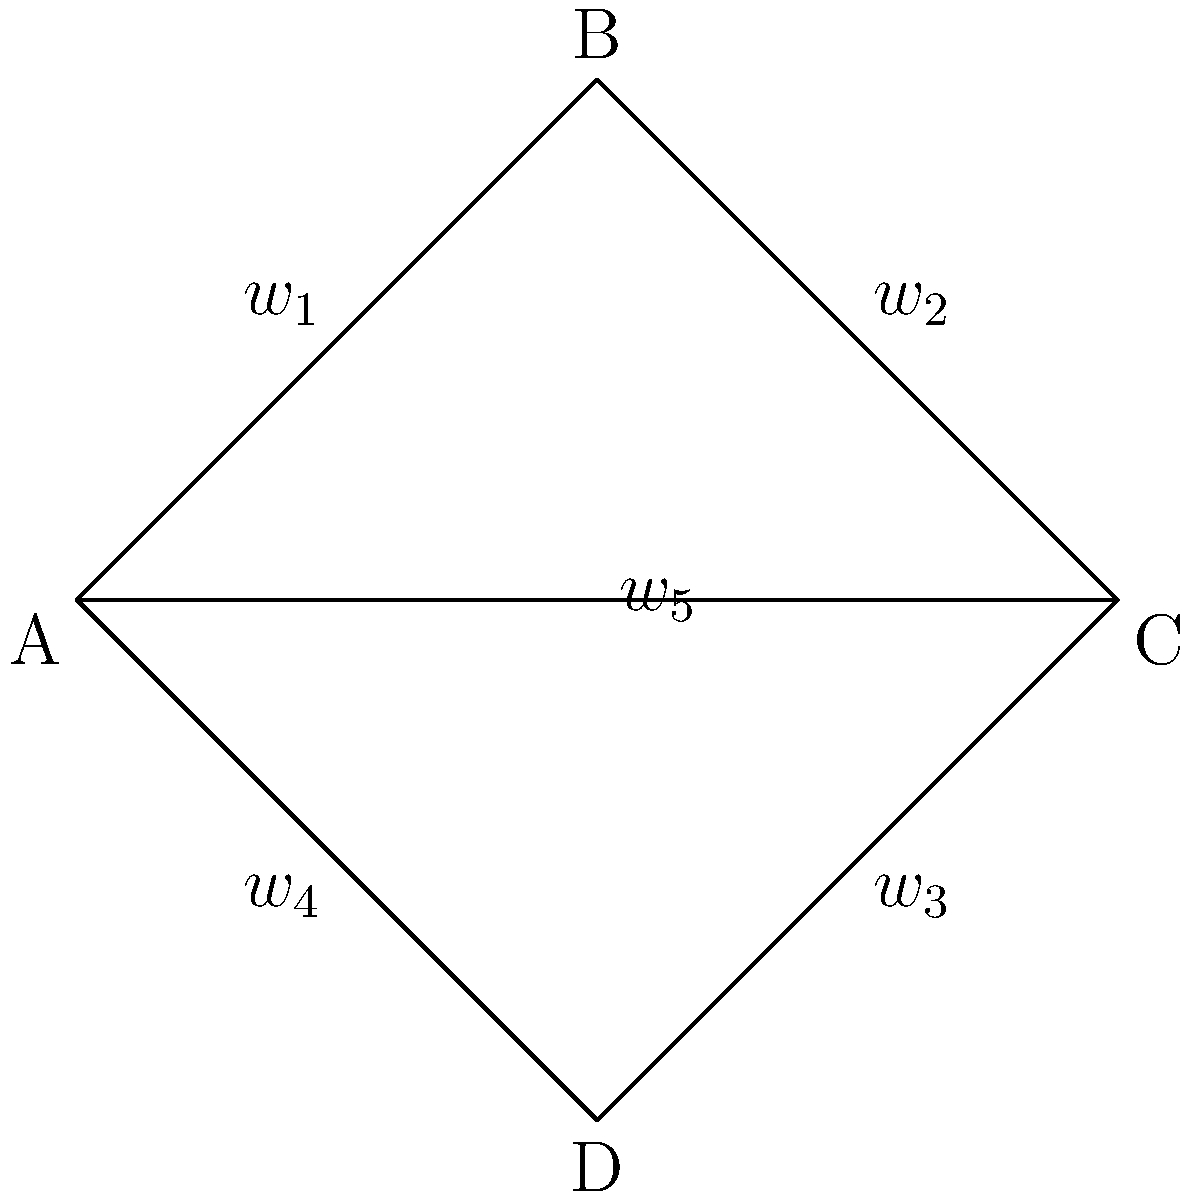Consider a network topology represented by the graph above, where vertices represent nodes and edges represent connections. The weight $w_i$ of each edge represents the maximum data transfer rate (in Gbps) between the connected nodes. The total data transfer rate of the network is given by the sum of all edge weights. If the weights are constrained by the equation $w_1^2 + w_2^2 + w_3^2 + w_4^2 + w_5^2 = 100$, determine the maximum possible total data transfer rate of the network and the corresponding weights that achieve this maximum. To solve this optimization problem, we can use the method of Lagrange multipliers:

1) Let $f(w_1, w_2, w_3, w_4, w_5) = w_1 + w_2 + w_3 + w_4 + w_5$ be the function we want to maximize.

2) The constraint is $g(w_1, w_2, w_3, w_4, w_5) = w_1^2 + w_2^2 + w_3^2 + w_4^2 + w_5^2 - 100 = 0$.

3) Form the Lagrangian: $L(w_1, w_2, w_3, w_4, w_5, \lambda) = f - \lambda g$

4) Take partial derivatives and set them equal to zero:
   
   $\frac{\partial L}{\partial w_i} = 1 - 2\lambda w_i = 0$ for $i = 1,2,3,4,5$
   
   $\frac{\partial L}{\partial \lambda} = w_1^2 + w_2^2 + w_3^2 + w_4^2 + w_5^2 - 100 = 0$

5) From the first equation, we get $w_i = \frac{1}{2\lambda}$ for all $i$.

6) Substituting this into the constraint equation:

   $5(\frac{1}{2\lambda})^2 = 100$

7) Solving for $\lambda$:

   $\lambda = \frac{\sqrt{5}}{20}$

8) Therefore, all weights are equal:

   $w_i = \frac{1}{2\lambda} = \frac{10}{\sqrt{5}}$ for all $i$

9) The maximum total data transfer rate is:

   $f_{max} = 5 \cdot \frac{10}{\sqrt{5}} = 10\sqrt{5}$ Gbps
Answer: Maximum total data transfer rate: $10\sqrt{5}$ Gbps; All weights: $\frac{10}{\sqrt{5}}$ Gbps 